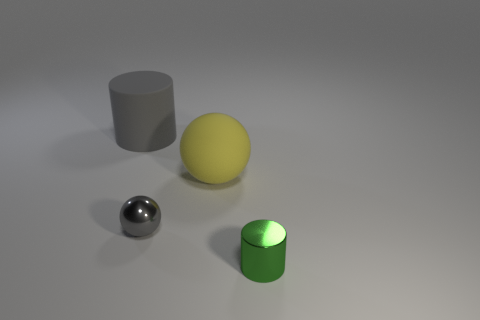Are there more large yellow rubber things on the right side of the metal sphere than gray spheres behind the big gray cylinder?
Offer a terse response. Yes. Does the thing left of the small sphere have the same material as the gray thing that is to the right of the matte cylinder?
Make the answer very short. No. There is a large gray matte thing; are there any cylinders right of it?
Give a very brief answer. Yes. What number of purple objects are tiny metallic objects or large matte spheres?
Your answer should be very brief. 0. Is the tiny cylinder made of the same material as the cylinder left of the green cylinder?
Your answer should be compact. No. There is a green object that is the same shape as the gray rubber object; what is its size?
Give a very brief answer. Small. What is the yellow sphere made of?
Keep it short and to the point. Rubber. What is the material of the gray object behind the sphere that is behind the shiny object left of the shiny cylinder?
Your answer should be very brief. Rubber. There is a matte object that is right of the rubber cylinder; is its size the same as the metallic object behind the green metal object?
Give a very brief answer. No. How many other objects are there of the same material as the tiny green cylinder?
Your answer should be compact. 1. 